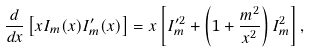Convert formula to latex. <formula><loc_0><loc_0><loc_500><loc_500>\frac { d } { d x } \left [ x I _ { m } ( x ) I ^ { \prime } _ { m } ( x ) \right ] = x \left [ I ^ { \prime 2 } _ { m } + \left ( 1 + \frac { m ^ { 2 } } { x ^ { 2 } } \right ) I ^ { 2 } _ { m } \right ] ,</formula> 